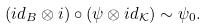Convert formula to latex. <formula><loc_0><loc_0><loc_500><loc_500>( i d _ { B } \otimes i ) \circ ( \psi \otimes i d _ { \mathcal { K } } ) \sim \psi _ { 0 } .</formula> 